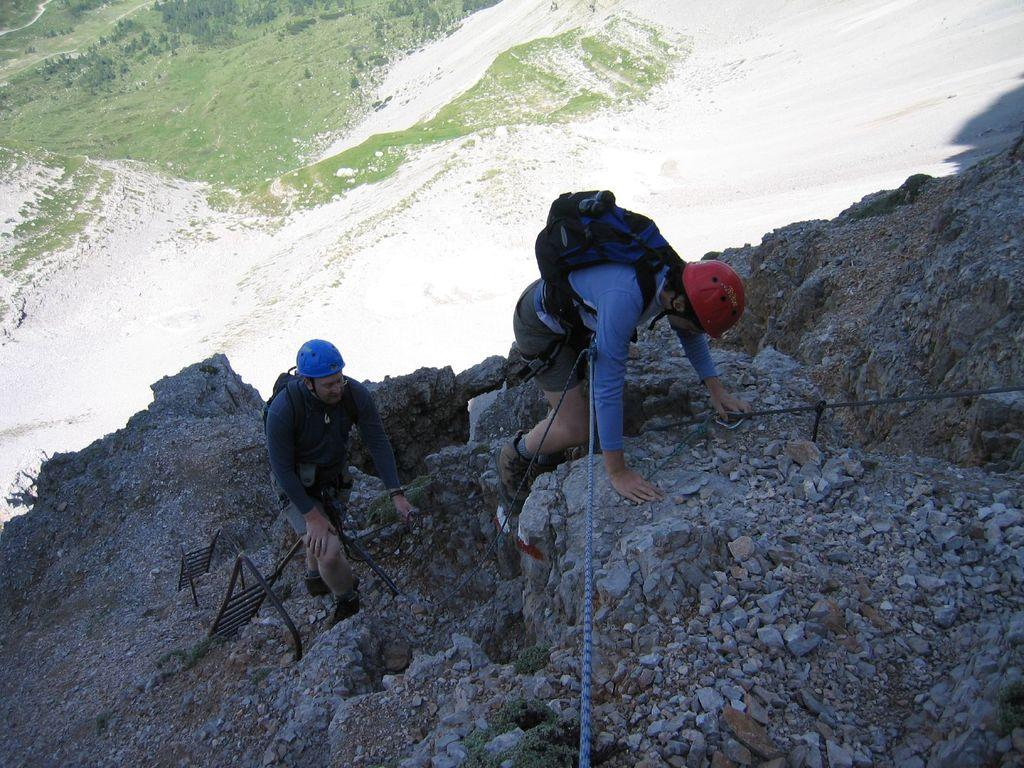How many people are in the image? There are two persons in the image. What are the persons doing in the image? The persons are climbing a mountain. What equipment are the persons wearing in the image? The persons are wearing bags and helmets. What can be seen in the background of the image? There is green land in the background of the image. What type of advice can be heard from the fog in the image? There is no fog present in the image, and therefore no advice can be heard from it. 